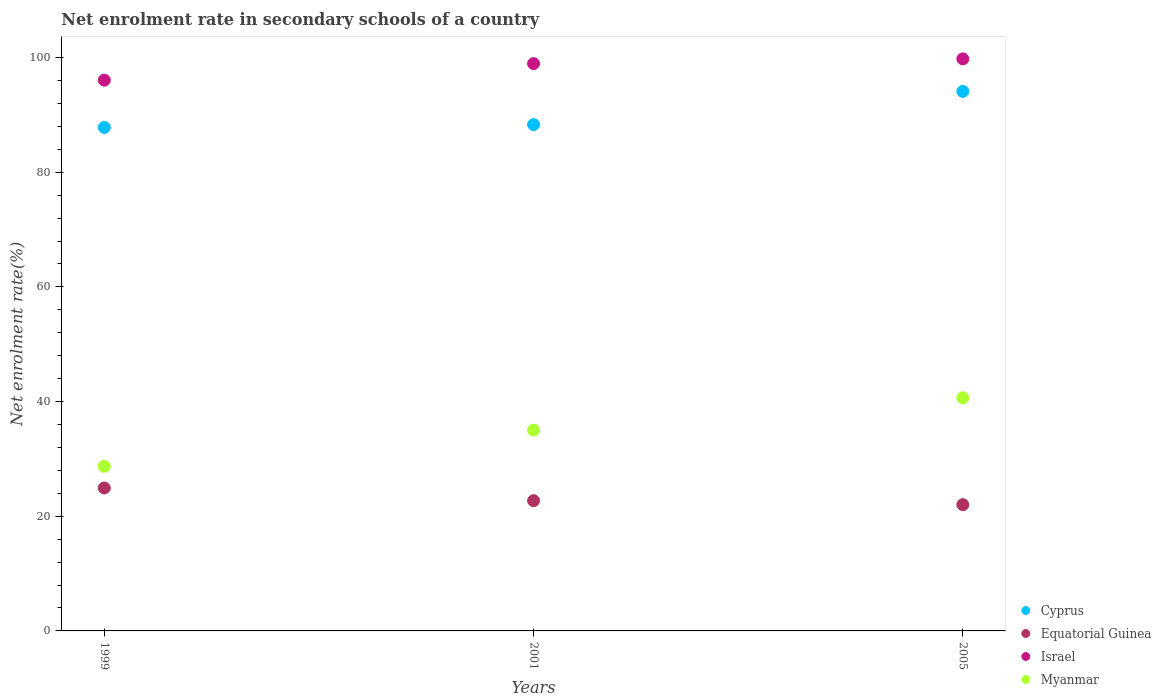How many different coloured dotlines are there?
Give a very brief answer. 4. Is the number of dotlines equal to the number of legend labels?
Give a very brief answer. Yes. What is the net enrolment rate in secondary schools in Israel in 2001?
Keep it short and to the point. 98.95. Across all years, what is the maximum net enrolment rate in secondary schools in Cyprus?
Ensure brevity in your answer.  94.1. Across all years, what is the minimum net enrolment rate in secondary schools in Equatorial Guinea?
Offer a terse response. 22.02. In which year was the net enrolment rate in secondary schools in Equatorial Guinea maximum?
Make the answer very short. 1999. What is the total net enrolment rate in secondary schools in Myanmar in the graph?
Your answer should be compact. 104.39. What is the difference between the net enrolment rate in secondary schools in Cyprus in 1999 and that in 2001?
Keep it short and to the point. -0.5. What is the difference between the net enrolment rate in secondary schools in Equatorial Guinea in 1999 and the net enrolment rate in secondary schools in Myanmar in 2005?
Provide a succinct answer. -15.73. What is the average net enrolment rate in secondary schools in Israel per year?
Offer a terse response. 98.26. In the year 2005, what is the difference between the net enrolment rate in secondary schools in Israel and net enrolment rate in secondary schools in Equatorial Guinea?
Offer a very short reply. 77.75. In how many years, is the net enrolment rate in secondary schools in Cyprus greater than 20 %?
Give a very brief answer. 3. What is the ratio of the net enrolment rate in secondary schools in Myanmar in 2001 to that in 2005?
Ensure brevity in your answer.  0.86. Is the net enrolment rate in secondary schools in Israel in 1999 less than that in 2005?
Offer a very short reply. Yes. Is the difference between the net enrolment rate in secondary schools in Israel in 1999 and 2001 greater than the difference between the net enrolment rate in secondary schools in Equatorial Guinea in 1999 and 2001?
Ensure brevity in your answer.  No. What is the difference between the highest and the second highest net enrolment rate in secondary schools in Myanmar?
Offer a terse response. 5.63. What is the difference between the highest and the lowest net enrolment rate in secondary schools in Israel?
Your response must be concise. 3.71. Is the net enrolment rate in secondary schools in Cyprus strictly greater than the net enrolment rate in secondary schools in Equatorial Guinea over the years?
Your answer should be compact. Yes. Is the net enrolment rate in secondary schools in Myanmar strictly less than the net enrolment rate in secondary schools in Israel over the years?
Offer a terse response. Yes. How many dotlines are there?
Offer a terse response. 4. Are the values on the major ticks of Y-axis written in scientific E-notation?
Your answer should be compact. No. Does the graph contain grids?
Provide a succinct answer. No. How many legend labels are there?
Your answer should be compact. 4. How are the legend labels stacked?
Offer a very short reply. Vertical. What is the title of the graph?
Offer a very short reply. Net enrolment rate in secondary schools of a country. What is the label or title of the Y-axis?
Your answer should be compact. Net enrolment rate(%). What is the Net enrolment rate(%) in Cyprus in 1999?
Offer a very short reply. 87.81. What is the Net enrolment rate(%) of Equatorial Guinea in 1999?
Offer a very short reply. 24.93. What is the Net enrolment rate(%) of Israel in 1999?
Provide a short and direct response. 96.06. What is the Net enrolment rate(%) of Myanmar in 1999?
Your answer should be very brief. 28.71. What is the Net enrolment rate(%) of Cyprus in 2001?
Your response must be concise. 88.31. What is the Net enrolment rate(%) of Equatorial Guinea in 2001?
Keep it short and to the point. 22.71. What is the Net enrolment rate(%) in Israel in 2001?
Ensure brevity in your answer.  98.95. What is the Net enrolment rate(%) of Myanmar in 2001?
Your response must be concise. 35.02. What is the Net enrolment rate(%) in Cyprus in 2005?
Offer a terse response. 94.1. What is the Net enrolment rate(%) in Equatorial Guinea in 2005?
Provide a short and direct response. 22.02. What is the Net enrolment rate(%) of Israel in 2005?
Ensure brevity in your answer.  99.77. What is the Net enrolment rate(%) of Myanmar in 2005?
Make the answer very short. 40.66. Across all years, what is the maximum Net enrolment rate(%) of Cyprus?
Offer a very short reply. 94.1. Across all years, what is the maximum Net enrolment rate(%) in Equatorial Guinea?
Your response must be concise. 24.93. Across all years, what is the maximum Net enrolment rate(%) in Israel?
Provide a short and direct response. 99.77. Across all years, what is the maximum Net enrolment rate(%) in Myanmar?
Make the answer very short. 40.66. Across all years, what is the minimum Net enrolment rate(%) in Cyprus?
Provide a short and direct response. 87.81. Across all years, what is the minimum Net enrolment rate(%) in Equatorial Guinea?
Your response must be concise. 22.02. Across all years, what is the minimum Net enrolment rate(%) of Israel?
Your answer should be compact. 96.06. Across all years, what is the minimum Net enrolment rate(%) of Myanmar?
Offer a very short reply. 28.71. What is the total Net enrolment rate(%) of Cyprus in the graph?
Offer a terse response. 270.22. What is the total Net enrolment rate(%) of Equatorial Guinea in the graph?
Offer a terse response. 69.66. What is the total Net enrolment rate(%) of Israel in the graph?
Make the answer very short. 294.78. What is the total Net enrolment rate(%) in Myanmar in the graph?
Give a very brief answer. 104.39. What is the difference between the Net enrolment rate(%) in Cyprus in 1999 and that in 2001?
Your answer should be compact. -0.5. What is the difference between the Net enrolment rate(%) in Equatorial Guinea in 1999 and that in 2001?
Make the answer very short. 2.22. What is the difference between the Net enrolment rate(%) in Israel in 1999 and that in 2001?
Provide a succinct answer. -2.88. What is the difference between the Net enrolment rate(%) of Myanmar in 1999 and that in 2001?
Offer a very short reply. -6.32. What is the difference between the Net enrolment rate(%) in Cyprus in 1999 and that in 2005?
Offer a very short reply. -6.29. What is the difference between the Net enrolment rate(%) of Equatorial Guinea in 1999 and that in 2005?
Give a very brief answer. 2.91. What is the difference between the Net enrolment rate(%) of Israel in 1999 and that in 2005?
Provide a succinct answer. -3.71. What is the difference between the Net enrolment rate(%) in Myanmar in 1999 and that in 2005?
Provide a short and direct response. -11.95. What is the difference between the Net enrolment rate(%) of Cyprus in 2001 and that in 2005?
Offer a very short reply. -5.79. What is the difference between the Net enrolment rate(%) in Equatorial Guinea in 2001 and that in 2005?
Your answer should be compact. 0.69. What is the difference between the Net enrolment rate(%) of Israel in 2001 and that in 2005?
Your answer should be compact. -0.83. What is the difference between the Net enrolment rate(%) of Myanmar in 2001 and that in 2005?
Offer a terse response. -5.63. What is the difference between the Net enrolment rate(%) in Cyprus in 1999 and the Net enrolment rate(%) in Equatorial Guinea in 2001?
Ensure brevity in your answer.  65.1. What is the difference between the Net enrolment rate(%) in Cyprus in 1999 and the Net enrolment rate(%) in Israel in 2001?
Offer a terse response. -11.13. What is the difference between the Net enrolment rate(%) of Cyprus in 1999 and the Net enrolment rate(%) of Myanmar in 2001?
Ensure brevity in your answer.  52.79. What is the difference between the Net enrolment rate(%) of Equatorial Guinea in 1999 and the Net enrolment rate(%) of Israel in 2001?
Keep it short and to the point. -74.02. What is the difference between the Net enrolment rate(%) of Equatorial Guinea in 1999 and the Net enrolment rate(%) of Myanmar in 2001?
Your answer should be very brief. -10.1. What is the difference between the Net enrolment rate(%) of Israel in 1999 and the Net enrolment rate(%) of Myanmar in 2001?
Make the answer very short. 61.04. What is the difference between the Net enrolment rate(%) of Cyprus in 1999 and the Net enrolment rate(%) of Equatorial Guinea in 2005?
Your answer should be very brief. 65.79. What is the difference between the Net enrolment rate(%) in Cyprus in 1999 and the Net enrolment rate(%) in Israel in 2005?
Your response must be concise. -11.96. What is the difference between the Net enrolment rate(%) in Cyprus in 1999 and the Net enrolment rate(%) in Myanmar in 2005?
Offer a very short reply. 47.16. What is the difference between the Net enrolment rate(%) in Equatorial Guinea in 1999 and the Net enrolment rate(%) in Israel in 2005?
Your answer should be very brief. -74.84. What is the difference between the Net enrolment rate(%) in Equatorial Guinea in 1999 and the Net enrolment rate(%) in Myanmar in 2005?
Offer a very short reply. -15.73. What is the difference between the Net enrolment rate(%) of Israel in 1999 and the Net enrolment rate(%) of Myanmar in 2005?
Offer a very short reply. 55.41. What is the difference between the Net enrolment rate(%) in Cyprus in 2001 and the Net enrolment rate(%) in Equatorial Guinea in 2005?
Your answer should be very brief. 66.29. What is the difference between the Net enrolment rate(%) in Cyprus in 2001 and the Net enrolment rate(%) in Israel in 2005?
Offer a very short reply. -11.46. What is the difference between the Net enrolment rate(%) of Cyprus in 2001 and the Net enrolment rate(%) of Myanmar in 2005?
Offer a terse response. 47.65. What is the difference between the Net enrolment rate(%) in Equatorial Guinea in 2001 and the Net enrolment rate(%) in Israel in 2005?
Your response must be concise. -77.06. What is the difference between the Net enrolment rate(%) in Equatorial Guinea in 2001 and the Net enrolment rate(%) in Myanmar in 2005?
Keep it short and to the point. -17.94. What is the difference between the Net enrolment rate(%) of Israel in 2001 and the Net enrolment rate(%) of Myanmar in 2005?
Keep it short and to the point. 58.29. What is the average Net enrolment rate(%) in Cyprus per year?
Offer a very short reply. 90.07. What is the average Net enrolment rate(%) of Equatorial Guinea per year?
Ensure brevity in your answer.  23.22. What is the average Net enrolment rate(%) in Israel per year?
Offer a terse response. 98.26. What is the average Net enrolment rate(%) of Myanmar per year?
Offer a very short reply. 34.8. In the year 1999, what is the difference between the Net enrolment rate(%) in Cyprus and Net enrolment rate(%) in Equatorial Guinea?
Offer a very short reply. 62.88. In the year 1999, what is the difference between the Net enrolment rate(%) of Cyprus and Net enrolment rate(%) of Israel?
Your answer should be compact. -8.25. In the year 1999, what is the difference between the Net enrolment rate(%) in Cyprus and Net enrolment rate(%) in Myanmar?
Offer a very short reply. 59.11. In the year 1999, what is the difference between the Net enrolment rate(%) in Equatorial Guinea and Net enrolment rate(%) in Israel?
Your answer should be compact. -71.13. In the year 1999, what is the difference between the Net enrolment rate(%) of Equatorial Guinea and Net enrolment rate(%) of Myanmar?
Your response must be concise. -3.78. In the year 1999, what is the difference between the Net enrolment rate(%) of Israel and Net enrolment rate(%) of Myanmar?
Give a very brief answer. 67.36. In the year 2001, what is the difference between the Net enrolment rate(%) of Cyprus and Net enrolment rate(%) of Equatorial Guinea?
Your answer should be compact. 65.6. In the year 2001, what is the difference between the Net enrolment rate(%) in Cyprus and Net enrolment rate(%) in Israel?
Provide a succinct answer. -10.64. In the year 2001, what is the difference between the Net enrolment rate(%) of Cyprus and Net enrolment rate(%) of Myanmar?
Provide a succinct answer. 53.28. In the year 2001, what is the difference between the Net enrolment rate(%) of Equatorial Guinea and Net enrolment rate(%) of Israel?
Keep it short and to the point. -76.23. In the year 2001, what is the difference between the Net enrolment rate(%) of Equatorial Guinea and Net enrolment rate(%) of Myanmar?
Keep it short and to the point. -12.31. In the year 2001, what is the difference between the Net enrolment rate(%) of Israel and Net enrolment rate(%) of Myanmar?
Your answer should be very brief. 63.92. In the year 2005, what is the difference between the Net enrolment rate(%) of Cyprus and Net enrolment rate(%) of Equatorial Guinea?
Your response must be concise. 72.08. In the year 2005, what is the difference between the Net enrolment rate(%) of Cyprus and Net enrolment rate(%) of Israel?
Make the answer very short. -5.67. In the year 2005, what is the difference between the Net enrolment rate(%) in Cyprus and Net enrolment rate(%) in Myanmar?
Ensure brevity in your answer.  53.44. In the year 2005, what is the difference between the Net enrolment rate(%) of Equatorial Guinea and Net enrolment rate(%) of Israel?
Make the answer very short. -77.75. In the year 2005, what is the difference between the Net enrolment rate(%) in Equatorial Guinea and Net enrolment rate(%) in Myanmar?
Keep it short and to the point. -18.64. In the year 2005, what is the difference between the Net enrolment rate(%) of Israel and Net enrolment rate(%) of Myanmar?
Ensure brevity in your answer.  59.12. What is the ratio of the Net enrolment rate(%) of Equatorial Guinea in 1999 to that in 2001?
Ensure brevity in your answer.  1.1. What is the ratio of the Net enrolment rate(%) in Israel in 1999 to that in 2001?
Your answer should be compact. 0.97. What is the ratio of the Net enrolment rate(%) of Myanmar in 1999 to that in 2001?
Offer a terse response. 0.82. What is the ratio of the Net enrolment rate(%) of Cyprus in 1999 to that in 2005?
Your answer should be compact. 0.93. What is the ratio of the Net enrolment rate(%) in Equatorial Guinea in 1999 to that in 2005?
Provide a short and direct response. 1.13. What is the ratio of the Net enrolment rate(%) of Israel in 1999 to that in 2005?
Provide a short and direct response. 0.96. What is the ratio of the Net enrolment rate(%) in Myanmar in 1999 to that in 2005?
Offer a very short reply. 0.71. What is the ratio of the Net enrolment rate(%) of Cyprus in 2001 to that in 2005?
Make the answer very short. 0.94. What is the ratio of the Net enrolment rate(%) of Equatorial Guinea in 2001 to that in 2005?
Give a very brief answer. 1.03. What is the ratio of the Net enrolment rate(%) in Myanmar in 2001 to that in 2005?
Your response must be concise. 0.86. What is the difference between the highest and the second highest Net enrolment rate(%) of Cyprus?
Ensure brevity in your answer.  5.79. What is the difference between the highest and the second highest Net enrolment rate(%) in Equatorial Guinea?
Keep it short and to the point. 2.22. What is the difference between the highest and the second highest Net enrolment rate(%) of Israel?
Provide a succinct answer. 0.83. What is the difference between the highest and the second highest Net enrolment rate(%) in Myanmar?
Keep it short and to the point. 5.63. What is the difference between the highest and the lowest Net enrolment rate(%) of Cyprus?
Ensure brevity in your answer.  6.29. What is the difference between the highest and the lowest Net enrolment rate(%) of Equatorial Guinea?
Give a very brief answer. 2.91. What is the difference between the highest and the lowest Net enrolment rate(%) of Israel?
Provide a short and direct response. 3.71. What is the difference between the highest and the lowest Net enrolment rate(%) in Myanmar?
Provide a short and direct response. 11.95. 